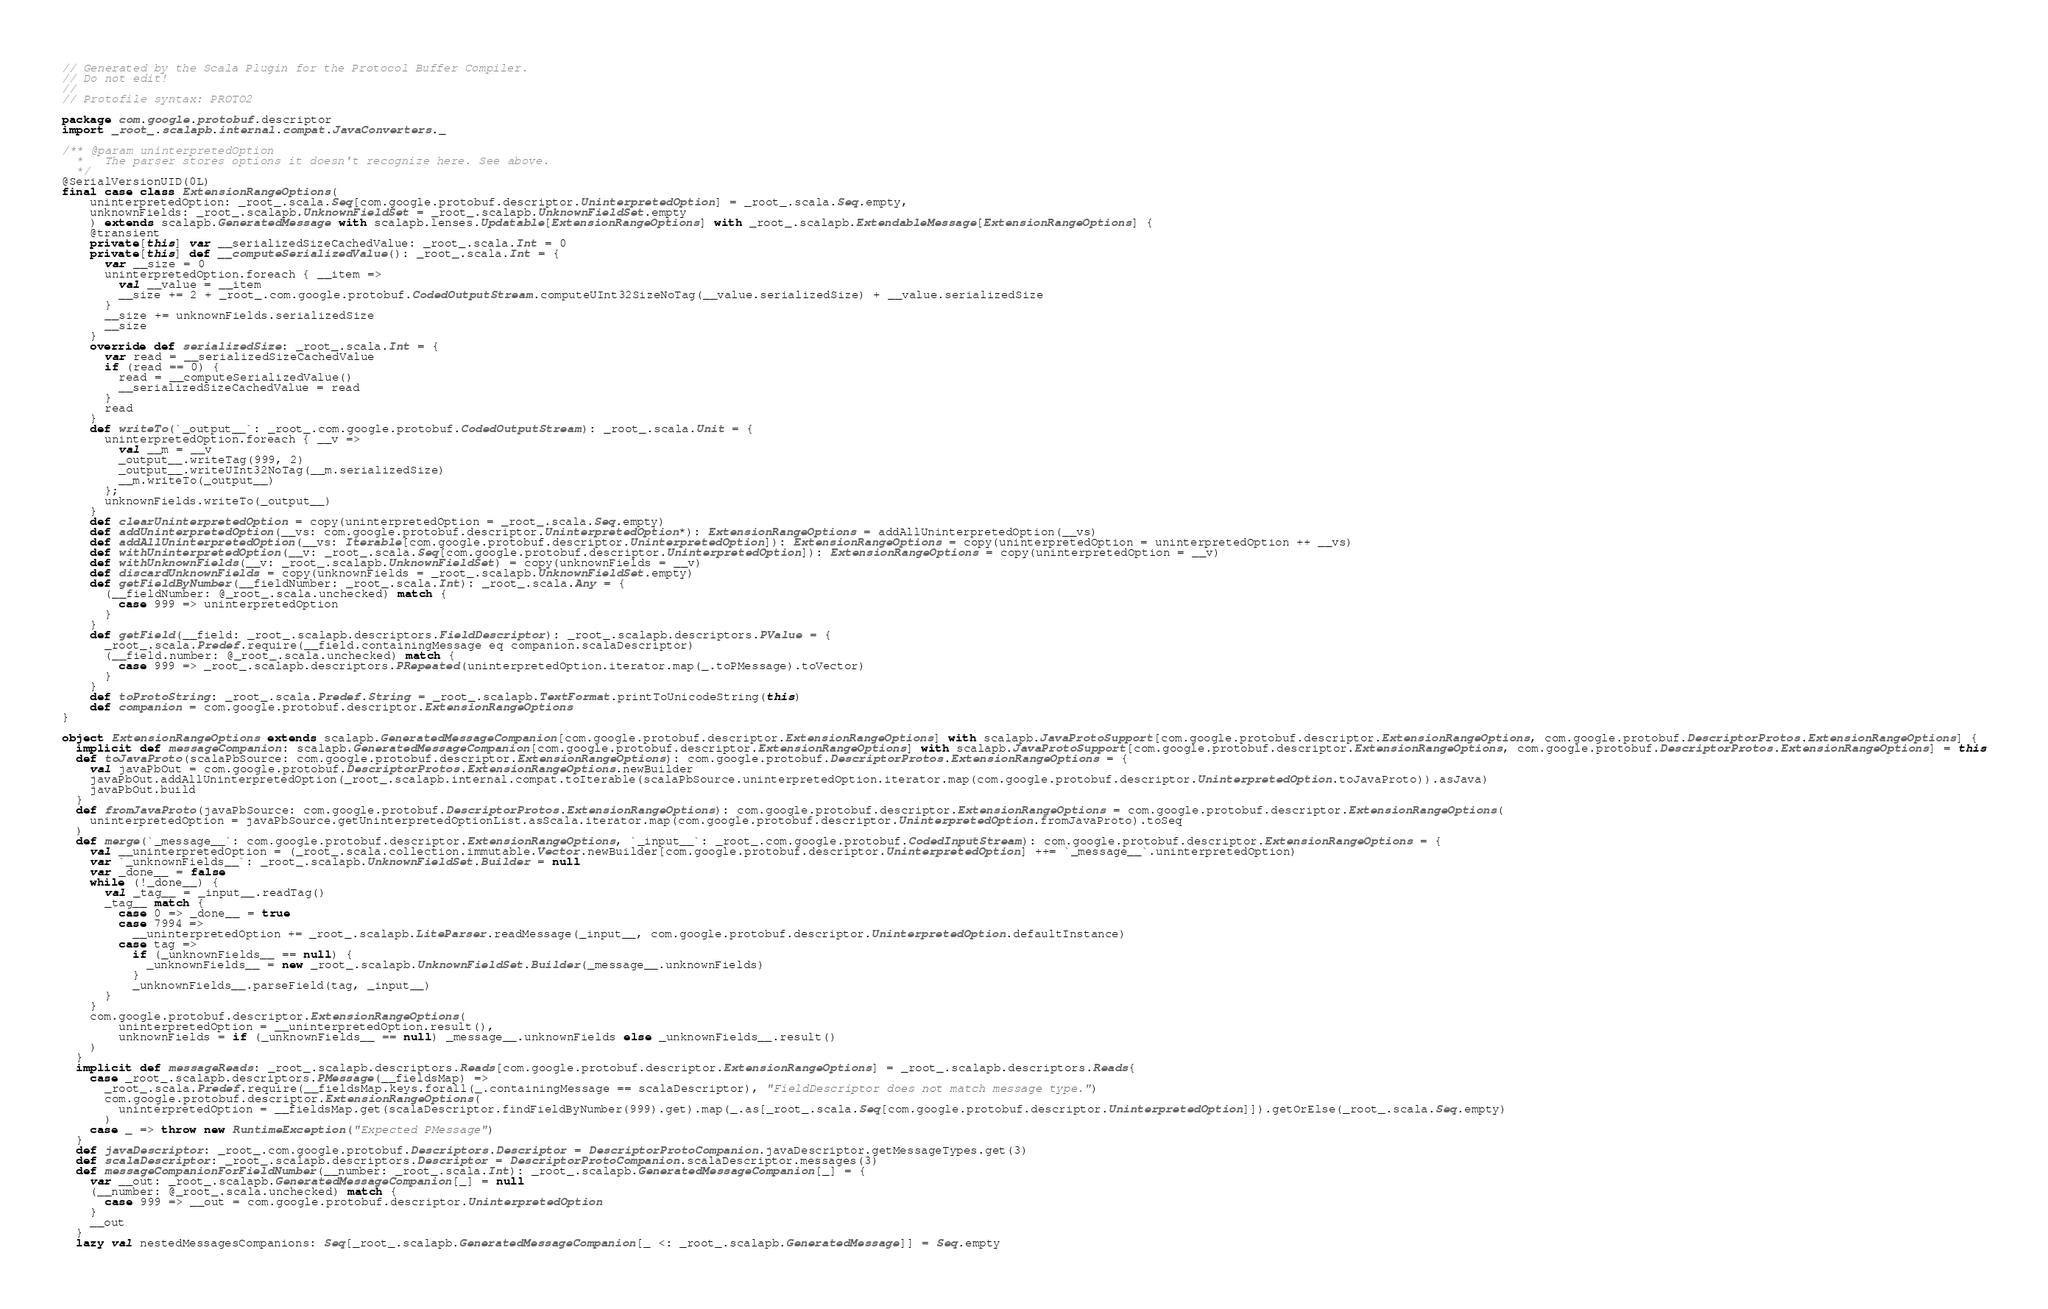<code> <loc_0><loc_0><loc_500><loc_500><_Scala_>// Generated by the Scala Plugin for the Protocol Buffer Compiler.
// Do not edit!
//
// Protofile syntax: PROTO2

package com.google.protobuf.descriptor
import _root_.scalapb.internal.compat.JavaConverters._

/** @param uninterpretedOption
  *   The parser stores options it doesn't recognize here. See above.
  */
@SerialVersionUID(0L)
final case class ExtensionRangeOptions(
    uninterpretedOption: _root_.scala.Seq[com.google.protobuf.descriptor.UninterpretedOption] = _root_.scala.Seq.empty,
    unknownFields: _root_.scalapb.UnknownFieldSet = _root_.scalapb.UnknownFieldSet.empty
    ) extends scalapb.GeneratedMessage with scalapb.lenses.Updatable[ExtensionRangeOptions] with _root_.scalapb.ExtendableMessage[ExtensionRangeOptions] {
    @transient
    private[this] var __serializedSizeCachedValue: _root_.scala.Int = 0
    private[this] def __computeSerializedValue(): _root_.scala.Int = {
      var __size = 0
      uninterpretedOption.foreach { __item =>
        val __value = __item
        __size += 2 + _root_.com.google.protobuf.CodedOutputStream.computeUInt32SizeNoTag(__value.serializedSize) + __value.serializedSize
      }
      __size += unknownFields.serializedSize
      __size
    }
    override def serializedSize: _root_.scala.Int = {
      var read = __serializedSizeCachedValue
      if (read == 0) {
        read = __computeSerializedValue()
        __serializedSizeCachedValue = read
      }
      read
    }
    def writeTo(`_output__`: _root_.com.google.protobuf.CodedOutputStream): _root_.scala.Unit = {
      uninterpretedOption.foreach { __v =>
        val __m = __v
        _output__.writeTag(999, 2)
        _output__.writeUInt32NoTag(__m.serializedSize)
        __m.writeTo(_output__)
      };
      unknownFields.writeTo(_output__)
    }
    def clearUninterpretedOption = copy(uninterpretedOption = _root_.scala.Seq.empty)
    def addUninterpretedOption(__vs: com.google.protobuf.descriptor.UninterpretedOption*): ExtensionRangeOptions = addAllUninterpretedOption(__vs)
    def addAllUninterpretedOption(__vs: Iterable[com.google.protobuf.descriptor.UninterpretedOption]): ExtensionRangeOptions = copy(uninterpretedOption = uninterpretedOption ++ __vs)
    def withUninterpretedOption(__v: _root_.scala.Seq[com.google.protobuf.descriptor.UninterpretedOption]): ExtensionRangeOptions = copy(uninterpretedOption = __v)
    def withUnknownFields(__v: _root_.scalapb.UnknownFieldSet) = copy(unknownFields = __v)
    def discardUnknownFields = copy(unknownFields = _root_.scalapb.UnknownFieldSet.empty)
    def getFieldByNumber(__fieldNumber: _root_.scala.Int): _root_.scala.Any = {
      (__fieldNumber: @_root_.scala.unchecked) match {
        case 999 => uninterpretedOption
      }
    }
    def getField(__field: _root_.scalapb.descriptors.FieldDescriptor): _root_.scalapb.descriptors.PValue = {
      _root_.scala.Predef.require(__field.containingMessage eq companion.scalaDescriptor)
      (__field.number: @_root_.scala.unchecked) match {
        case 999 => _root_.scalapb.descriptors.PRepeated(uninterpretedOption.iterator.map(_.toPMessage).toVector)
      }
    }
    def toProtoString: _root_.scala.Predef.String = _root_.scalapb.TextFormat.printToUnicodeString(this)
    def companion = com.google.protobuf.descriptor.ExtensionRangeOptions
}

object ExtensionRangeOptions extends scalapb.GeneratedMessageCompanion[com.google.protobuf.descriptor.ExtensionRangeOptions] with scalapb.JavaProtoSupport[com.google.protobuf.descriptor.ExtensionRangeOptions, com.google.protobuf.DescriptorProtos.ExtensionRangeOptions] {
  implicit def messageCompanion: scalapb.GeneratedMessageCompanion[com.google.protobuf.descriptor.ExtensionRangeOptions] with scalapb.JavaProtoSupport[com.google.protobuf.descriptor.ExtensionRangeOptions, com.google.protobuf.DescriptorProtos.ExtensionRangeOptions] = this
  def toJavaProto(scalaPbSource: com.google.protobuf.descriptor.ExtensionRangeOptions): com.google.protobuf.DescriptorProtos.ExtensionRangeOptions = {
    val javaPbOut = com.google.protobuf.DescriptorProtos.ExtensionRangeOptions.newBuilder
    javaPbOut.addAllUninterpretedOption(_root_.scalapb.internal.compat.toIterable(scalaPbSource.uninterpretedOption.iterator.map(com.google.protobuf.descriptor.UninterpretedOption.toJavaProto)).asJava)
    javaPbOut.build
  }
  def fromJavaProto(javaPbSource: com.google.protobuf.DescriptorProtos.ExtensionRangeOptions): com.google.protobuf.descriptor.ExtensionRangeOptions = com.google.protobuf.descriptor.ExtensionRangeOptions(
    uninterpretedOption = javaPbSource.getUninterpretedOptionList.asScala.iterator.map(com.google.protobuf.descriptor.UninterpretedOption.fromJavaProto).toSeq
  )
  def merge(`_message__`: com.google.protobuf.descriptor.ExtensionRangeOptions, `_input__`: _root_.com.google.protobuf.CodedInputStream): com.google.protobuf.descriptor.ExtensionRangeOptions = {
    val __uninterpretedOption = (_root_.scala.collection.immutable.Vector.newBuilder[com.google.protobuf.descriptor.UninterpretedOption] ++= `_message__`.uninterpretedOption)
    var `_unknownFields__`: _root_.scalapb.UnknownFieldSet.Builder = null
    var _done__ = false
    while (!_done__) {
      val _tag__ = _input__.readTag()
      _tag__ match {
        case 0 => _done__ = true
        case 7994 =>
          __uninterpretedOption += _root_.scalapb.LiteParser.readMessage(_input__, com.google.protobuf.descriptor.UninterpretedOption.defaultInstance)
        case tag =>
          if (_unknownFields__ == null) {
            _unknownFields__ = new _root_.scalapb.UnknownFieldSet.Builder(_message__.unknownFields)
          }
          _unknownFields__.parseField(tag, _input__)
      }
    }
    com.google.protobuf.descriptor.ExtensionRangeOptions(
        uninterpretedOption = __uninterpretedOption.result(),
        unknownFields = if (_unknownFields__ == null) _message__.unknownFields else _unknownFields__.result()
    )
  }
  implicit def messageReads: _root_.scalapb.descriptors.Reads[com.google.protobuf.descriptor.ExtensionRangeOptions] = _root_.scalapb.descriptors.Reads{
    case _root_.scalapb.descriptors.PMessage(__fieldsMap) =>
      _root_.scala.Predef.require(__fieldsMap.keys.forall(_.containingMessage == scalaDescriptor), "FieldDescriptor does not match message type.")
      com.google.protobuf.descriptor.ExtensionRangeOptions(
        uninterpretedOption = __fieldsMap.get(scalaDescriptor.findFieldByNumber(999).get).map(_.as[_root_.scala.Seq[com.google.protobuf.descriptor.UninterpretedOption]]).getOrElse(_root_.scala.Seq.empty)
      )
    case _ => throw new RuntimeException("Expected PMessage")
  }
  def javaDescriptor: _root_.com.google.protobuf.Descriptors.Descriptor = DescriptorProtoCompanion.javaDescriptor.getMessageTypes.get(3)
  def scalaDescriptor: _root_.scalapb.descriptors.Descriptor = DescriptorProtoCompanion.scalaDescriptor.messages(3)
  def messageCompanionForFieldNumber(__number: _root_.scala.Int): _root_.scalapb.GeneratedMessageCompanion[_] = {
    var __out: _root_.scalapb.GeneratedMessageCompanion[_] = null
    (__number: @_root_.scala.unchecked) match {
      case 999 => __out = com.google.protobuf.descriptor.UninterpretedOption
    }
    __out
  }
  lazy val nestedMessagesCompanions: Seq[_root_.scalapb.GeneratedMessageCompanion[_ <: _root_.scalapb.GeneratedMessage]] = Seq.empty</code> 